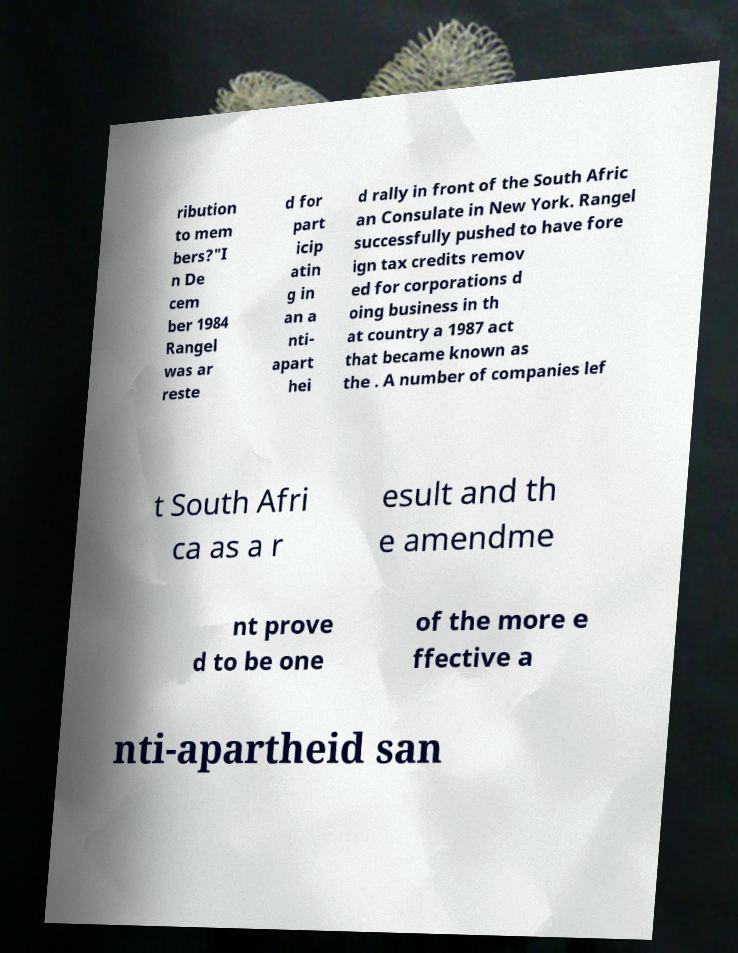There's text embedded in this image that I need extracted. Can you transcribe it verbatim? ribution to mem bers?"I n De cem ber 1984 Rangel was ar reste d for part icip atin g in an a nti- apart hei d rally in front of the South Afric an Consulate in New York. Rangel successfully pushed to have fore ign tax credits remov ed for corporations d oing business in th at country a 1987 act that became known as the . A number of companies lef t South Afri ca as a r esult and th e amendme nt prove d to be one of the more e ffective a nti-apartheid san 